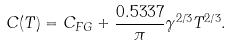Convert formula to latex. <formula><loc_0><loc_0><loc_500><loc_500>C ( T ) = C _ { F G } + \frac { 0 . 5 3 3 7 } { \pi } \gamma ^ { 2 / 3 } T ^ { 2 / 3 } .</formula> 